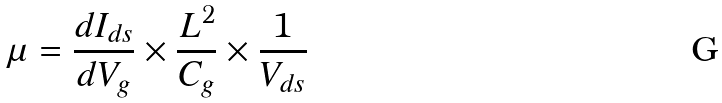<formula> <loc_0><loc_0><loc_500><loc_500>\mu = \frac { d I _ { d s } } { d V _ { g } } \times \frac { L ^ { 2 } } { C _ { g } } \times \frac { 1 } { V _ { d s } }</formula> 